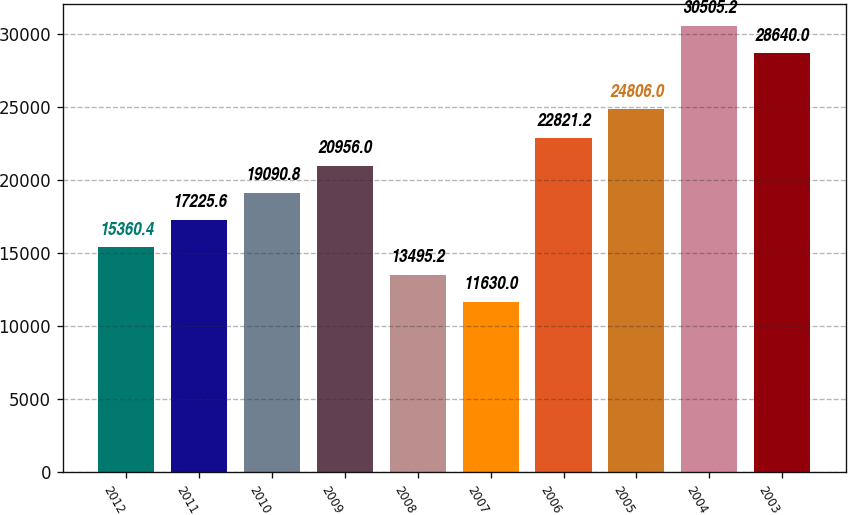<chart> <loc_0><loc_0><loc_500><loc_500><bar_chart><fcel>2012<fcel>2011<fcel>2010<fcel>2009<fcel>2008<fcel>2007<fcel>2006<fcel>2005<fcel>2004<fcel>2003<nl><fcel>15360.4<fcel>17225.6<fcel>19090.8<fcel>20956<fcel>13495.2<fcel>11630<fcel>22821.2<fcel>24806<fcel>30505.2<fcel>28640<nl></chart> 